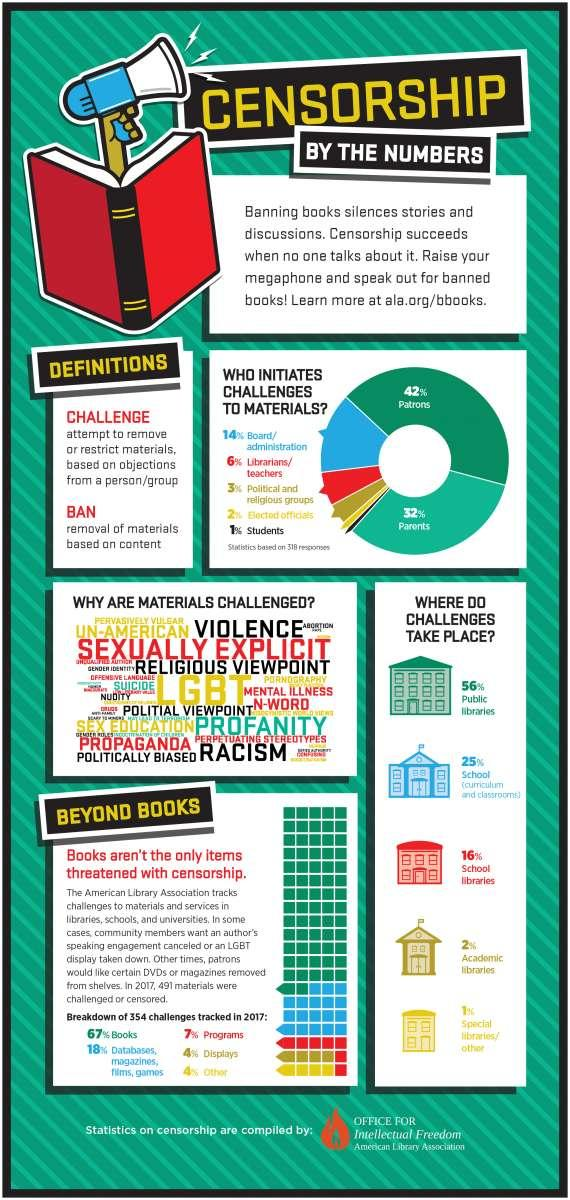Outline some significant characteristics in this image. According to the survey, 84% of the challenges reported did not occur in school libraries. Approximately 44% of challenges are not available in public libraries. According to the data, the majority of challenges are not specific to special libraries, with 99% of respondents indicating that their challenges apply to their general library setting. Patrons are the ones who initiate challenges to the materials the most. Seventy-five percent of challenges occur outside of school. 